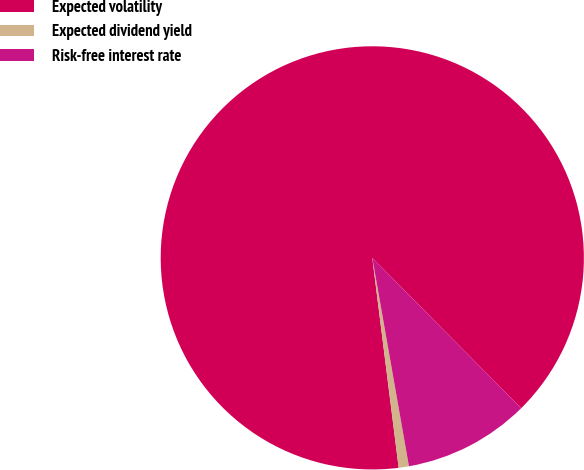Convert chart. <chart><loc_0><loc_0><loc_500><loc_500><pie_chart><fcel>Expected volatility<fcel>Expected dividend yield<fcel>Risk-free interest rate<nl><fcel>89.57%<fcel>0.78%<fcel>9.65%<nl></chart> 